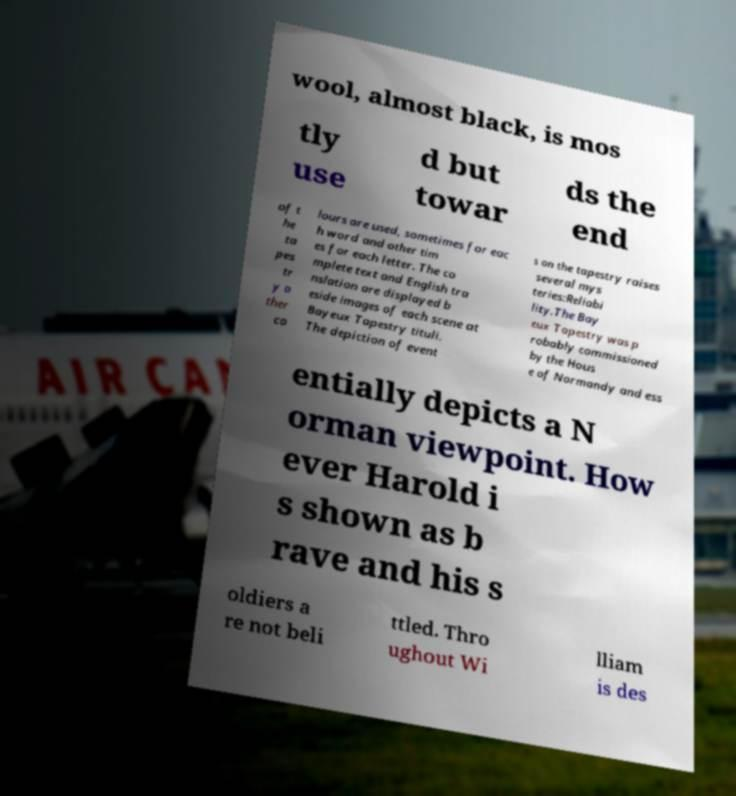Could you assist in decoding the text presented in this image and type it out clearly? wool, almost black, is mos tly use d but towar ds the end of t he ta pes tr y o ther co lours are used, sometimes for eac h word and other tim es for each letter. The co mplete text and English tra nslation are displayed b eside images of each scene at Bayeux Tapestry tituli. The depiction of event s on the tapestry raises several mys teries:Reliabi lity.The Bay eux Tapestry was p robably commissioned by the Hous e of Normandy and ess entially depicts a N orman viewpoint. How ever Harold i s shown as b rave and his s oldiers a re not beli ttled. Thro ughout Wi lliam is des 